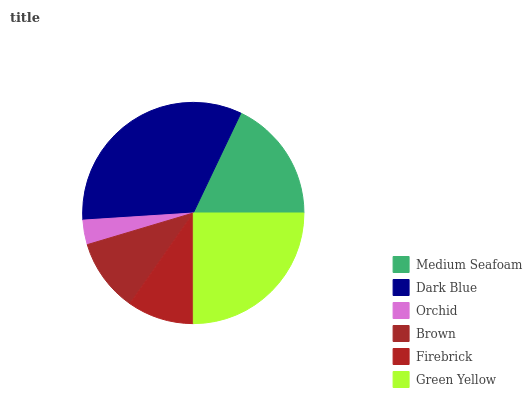Is Orchid the minimum?
Answer yes or no. Yes. Is Dark Blue the maximum?
Answer yes or no. Yes. Is Dark Blue the minimum?
Answer yes or no. No. Is Orchid the maximum?
Answer yes or no. No. Is Dark Blue greater than Orchid?
Answer yes or no. Yes. Is Orchid less than Dark Blue?
Answer yes or no. Yes. Is Orchid greater than Dark Blue?
Answer yes or no. No. Is Dark Blue less than Orchid?
Answer yes or no. No. Is Medium Seafoam the high median?
Answer yes or no. Yes. Is Brown the low median?
Answer yes or no. Yes. Is Orchid the high median?
Answer yes or no. No. Is Green Yellow the low median?
Answer yes or no. No. 